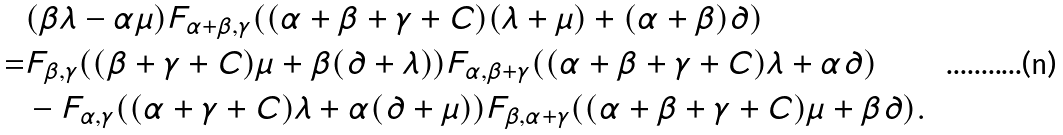Convert formula to latex. <formula><loc_0><loc_0><loc_500><loc_500>& ( \beta \lambda - \alpha \mu ) F _ { \alpha + \beta , \gamma } ( ( \alpha + \beta + \gamma + C ) ( \lambda + \mu ) + ( \alpha + \beta ) \partial ) \\ = & F _ { \beta , \gamma } ( ( \beta + \gamma + C ) \mu + \beta ( \partial + \lambda ) ) F _ { \alpha , \beta + \gamma } ( ( \alpha + \beta + \gamma + C ) \lambda + \alpha \partial ) \\ & - F _ { \alpha , \gamma } ( ( \alpha + \gamma + C ) \lambda + \alpha ( \partial + \mu ) ) F _ { \beta , \alpha + \gamma } ( ( \alpha + \beta + \gamma + C ) \mu + \beta \partial ) .</formula> 